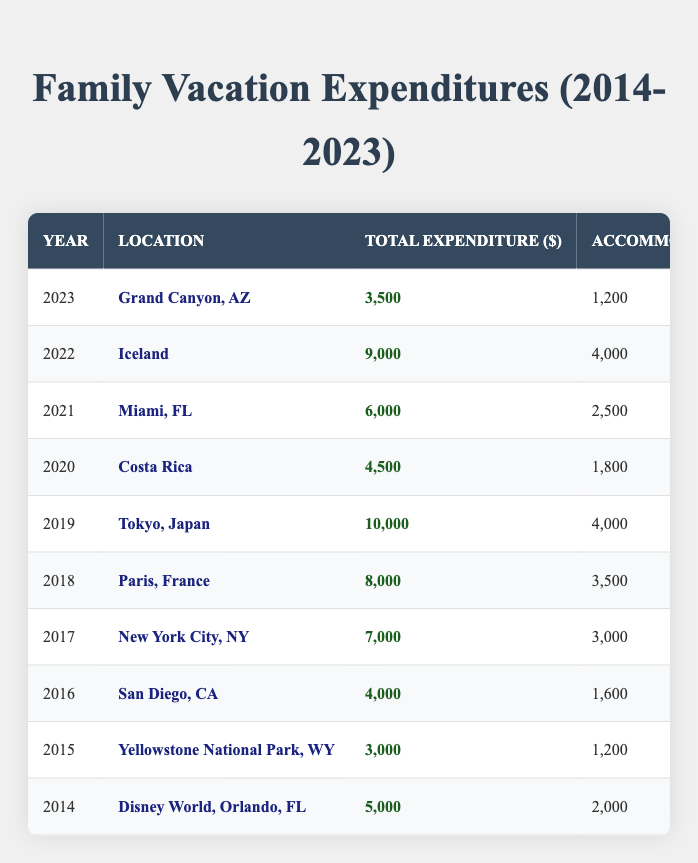What was the total expenditure for the family vacation in 2019? Referring to the table, in 2019, the total expenditure is listed as 10,000.
Answer: 10,000 Which location had the highest accommodation costs in 2022? Looking at the 2022 data in the table, the accommodation cost for Iceland is 4,000, which is higher than any other location listed that year.
Answer: Iceland In which year did the family spend the least on entertainment costs? Examining the entertainment costs row by row, the lowest entertainment cost is in 2015 for Yellowstone National Park, which is 600.
Answer: 2015 What is the difference in total expenditure between 2018 and 2021? The total expenditure for 2018 (8,000) minus the total expenditure for 2021 (6,000) gives a difference of 2,000.
Answer: 2,000 Which vacation had a total expenditure above 7,000 and was not in the United States? The 2019 (Tokyo, Japan) and 2018 (Paris, France) vacations each had expenditures above 7,000. Both are not in the United States.
Answer: Tokyo, Japan and Paris, France If we average the total expenditures from 2014 to 2023, what would that be? To find the average, sum all total expenditures (5,000 + 3,000 + 4,000 + 7,000 + 8,000 + 10,000 + 4,500 + 6,000 + 9,000 + 3,500 = 60,000) and divide by the number of years (10), which equals 6,000.
Answer: 6,000 Did the family spend more on food or transportation in 2020? In 2020, the table indicates that food costs 900, while transportation costs 600, meaning they spent more on food.
Answer: Yes How much did the family spend on food in 2017 compared to 2019? In 2017, food costs were 1,500 and in 2019 they were 3,000. The difference shows that 2019 had higher food costs (3,000 - 1,500 = 1,500 more spent).
Answer: 1,500 What was the trend in spending from 2014 to 2023? Analyzing the designations from each year, spending generally increased from 2014 to 2019 (steady rises). However, expenditures dipped in 2020 and again in 2023 before showing recovery in 2022. Thus, it's worth noting a fluctuating trend after 2019.
Answer: Fluctuating trend Which years showed a total expenditure of at least 7,000? By checking the table, the years 2017 (7,000), 2018 (8,000), and 2019 (10,000) all show total expenditures that reach or exceed 7,000.
Answer: 2017, 2018, 2019 